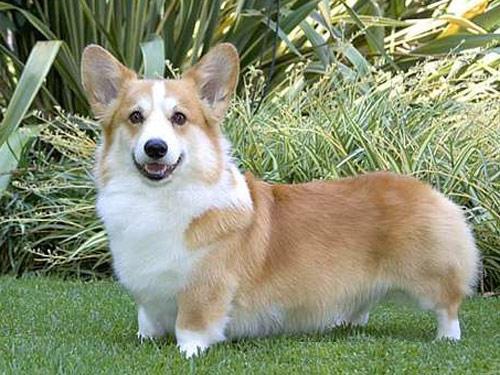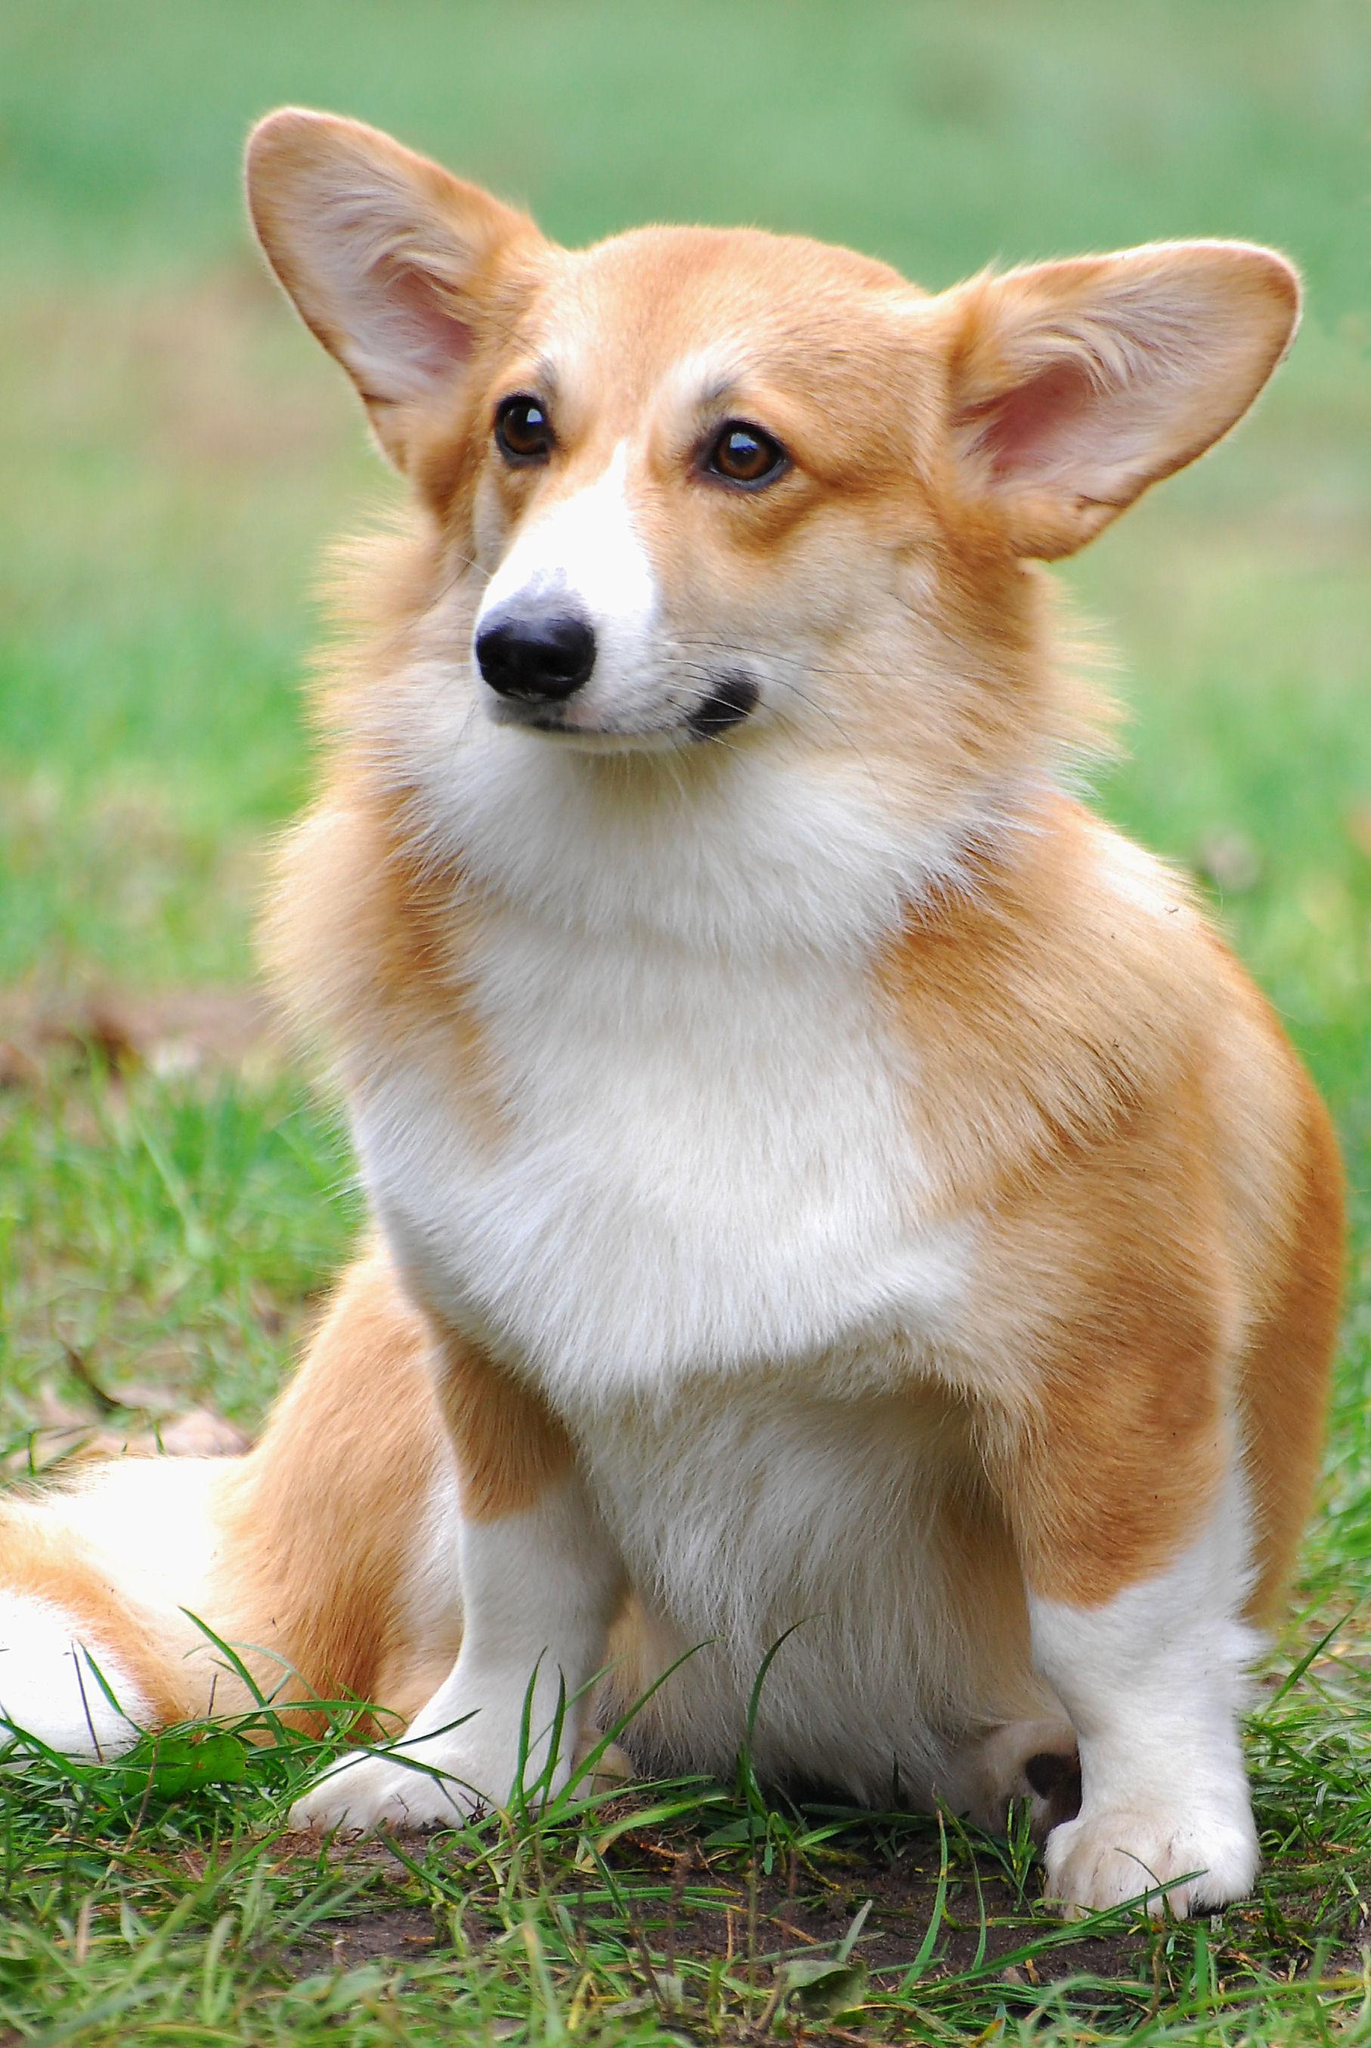The first image is the image on the left, the second image is the image on the right. Examine the images to the left and right. Is the description "The dog in the right image is not posed with grass in the background." accurate? Answer yes or no. No. 